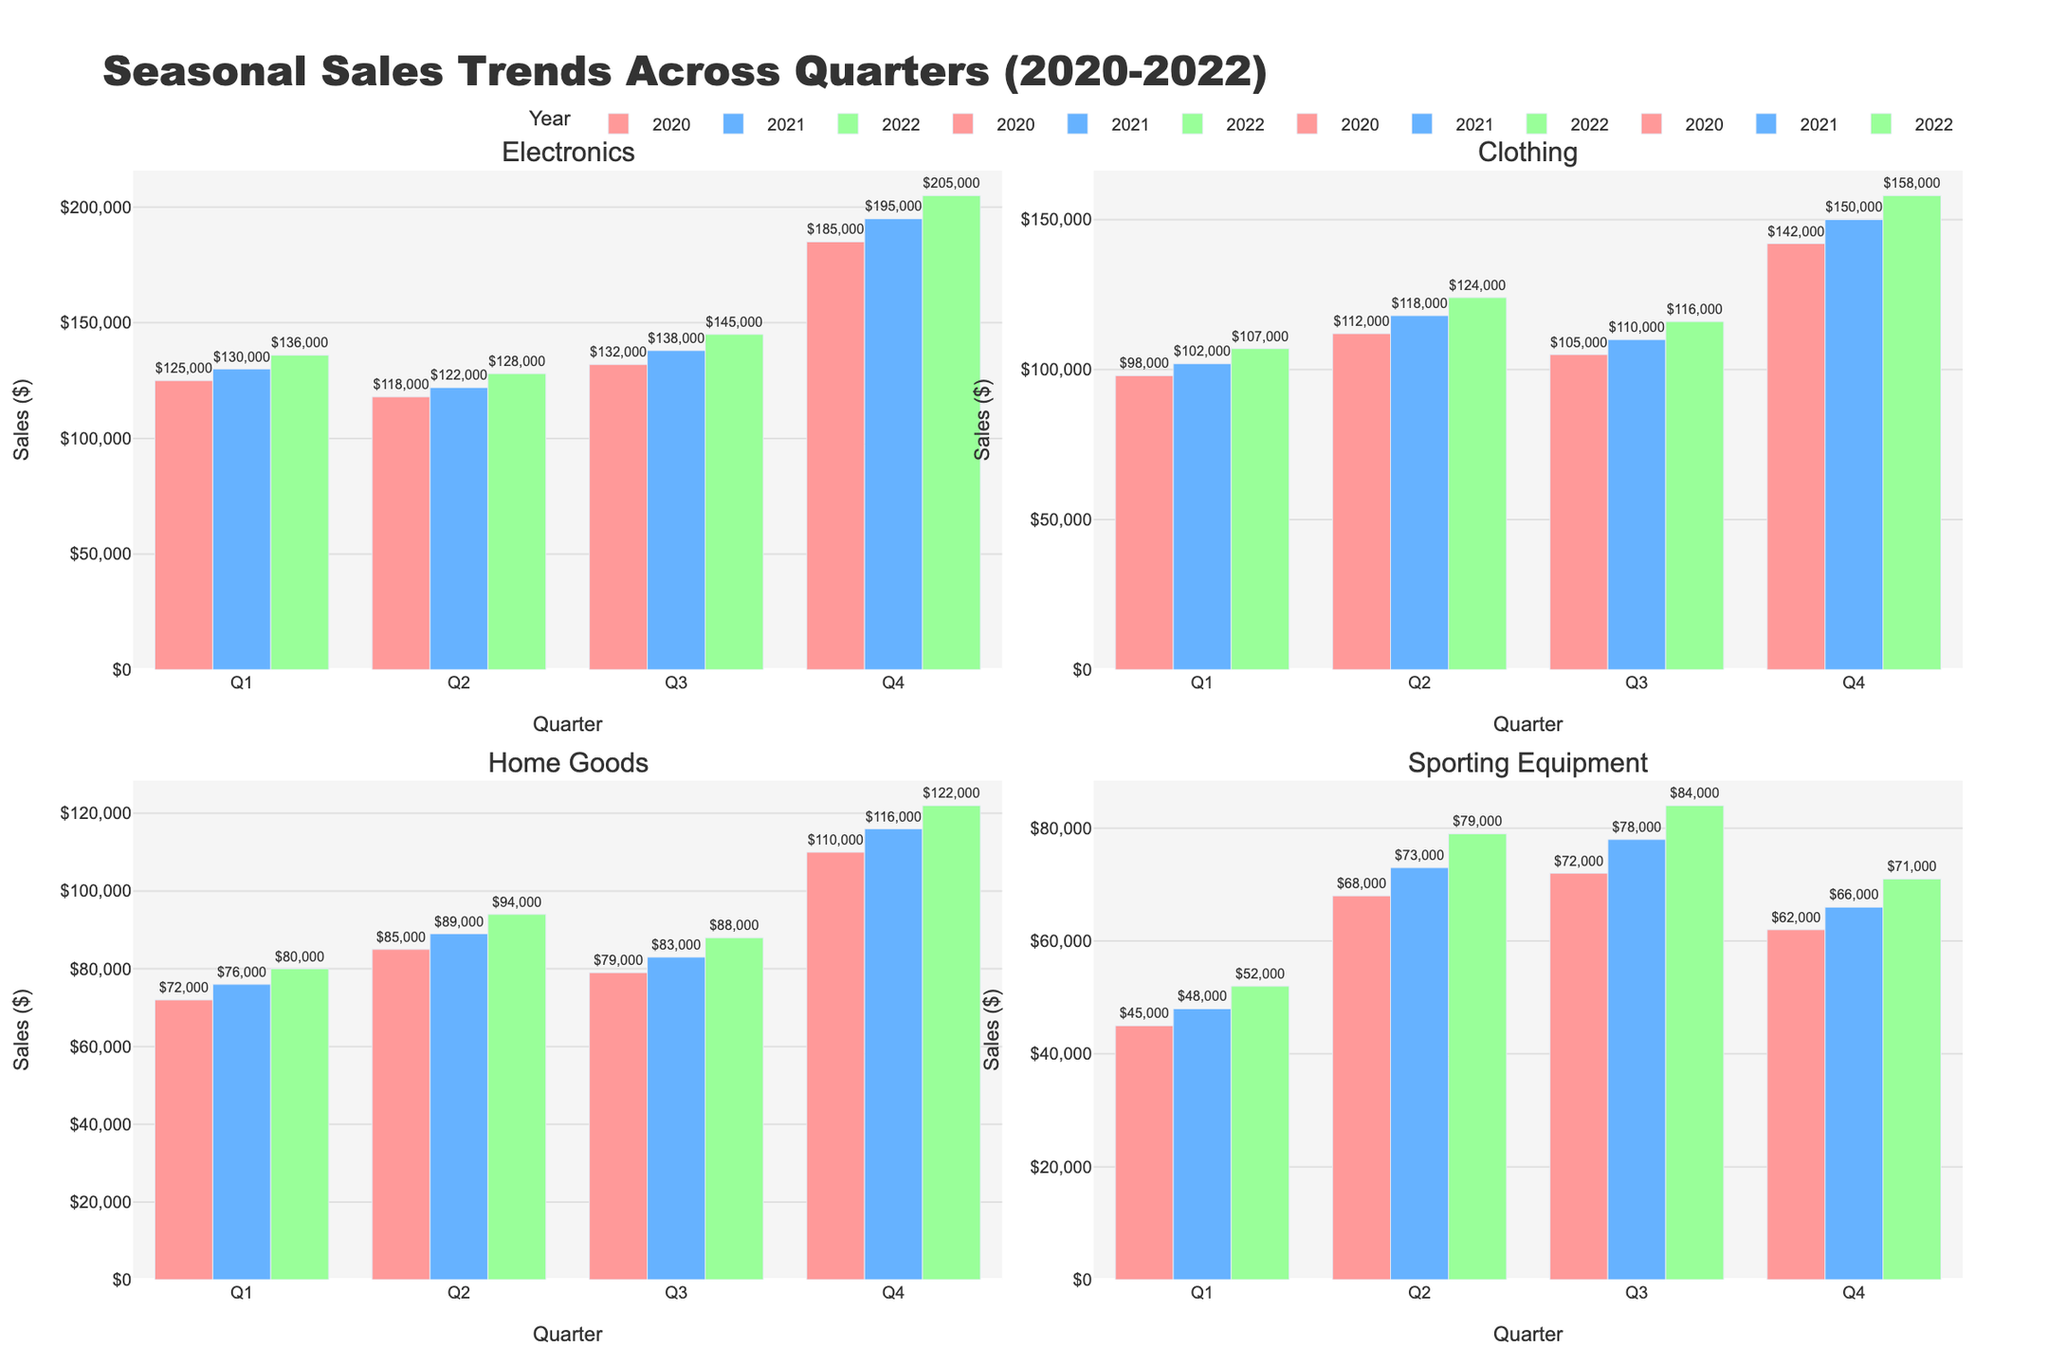What is the total sales for Electronics in Q4 across all three years? To calculate the total sales for Electronics in Q4 for all three years, add the sales for Electronics in Q4 of 2020, 2021, and 2022 respectively. So, 185,000 (Q4 2020) + 195,000 (Q4 2021) + 205,000 (Q4 2022) = 585,000.
Answer: 585,000 Which category had the highest sales in Q3 of 2022? To determine the category with the highest sales in Q3 of 2022, compare the sales values for all categories in Q3 2022. Electronics had 145,000, Clothing had 116,000, Home Goods had 88,000, and Sporting Equipment had 84,000. The highest is Electronics with 145,000.
Answer: Electronics Which quarter consistently had the highest sales for Clothing over the three years? Look at the sales figures for Clothing for each quarter across the three years. Summing each quarter over three years, Q1 is 98,000+102,000+107,000 = 307,000, Q2 is 112,000+118,000+124,000 = 354,000, Q3 is 105,000+110,000+116,000 = 331,000, and Q4 is 142,000+150,000+158,000 = 450,000. The quarter with the highest total is Q4.
Answer: Q4 Compare the sales of Home Goods in Q2 of 2021 and Q2 of 2022. Which quarter had higher sales and by how much? Compare the sales values of Home Goods in Q2 of 2021 which is 89,000 and Q2 of 2022 which is 94,000. Q2 of 2022 had higher sales by 94,000 - 89,000 = 5,000.
Answer: Q2 2022 by 5,000 What is the average sales of Sporting Equipment across all quarters in 2021? Add the sales for Sporting Equipment in all quarters of 2021 and divide by the number of quarters. So, (48,000 + 73,000 + 78,000 + 66,000) / 4 = 265,000 / 4 = 66,250.
Answer: 66,250 How did the sales of Electronics in Q1 change from 2020 to 2022? To evaluate the change, subtract the sales in Q1 2020 from Q1 2022. So, 136,000 (Q1 2022) - 125,000 (Q1 2020) = 11,000 increase.
Answer: Increased by 11,000 During which quarter in 2020 did Sporting Equipment have the lowest sales, and what was the amount? Examine each quarter's sales for Sporting Equipment in 2020. Q1 had 45,000, Q2 had 68,000, Q3 had 72,000, and Q4 had 62,000. The lowest was in Q1 with 45,000.
Answer: Q1 with 45,000 What trend do you observe for Clothing sales in Q4 from 2020 to 2022? The sales for Clothing in Q4 over the years 2020, 2021, and 2022 are 142,000, 150,000, and 158,000 respectively. The trend shows an increasing pattern.
Answer: Increasing trend Compare the overall sales of Home Goods in 2021 and 2022. Which year saw higher sales and by how much? Sum the sales of Home Goods for each quarter in 2021 and 2022. For 2021, 76,000 + 89,000 + 83,000 + 116,000 = 364,000. For 2022, 80,000 + 94,000 + 88,000 + 122,000 = 384,000. 2022 saw higher sales by 384,000 - 364,000 = 20,000.
Answer: 2022 by 20,000 